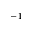<formula> <loc_0><loc_0><loc_500><loc_500>^ { - 1 }</formula> 